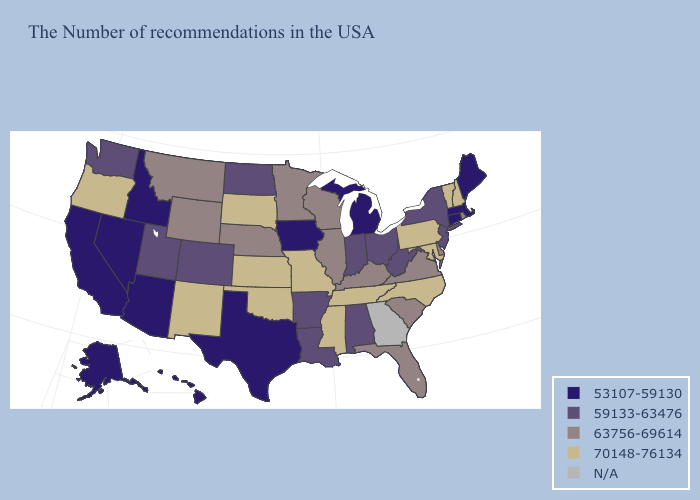Name the states that have a value in the range 70148-76134?
Be succinct. New Hampshire, Vermont, Maryland, Pennsylvania, North Carolina, Tennessee, Mississippi, Missouri, Kansas, Oklahoma, South Dakota, New Mexico, Oregon. What is the value of Minnesota?
Write a very short answer. 63756-69614. Name the states that have a value in the range 63756-69614?
Concise answer only. Rhode Island, Delaware, Virginia, South Carolina, Florida, Kentucky, Wisconsin, Illinois, Minnesota, Nebraska, Wyoming, Montana. What is the highest value in the West ?
Give a very brief answer. 70148-76134. What is the value of Wisconsin?
Short answer required. 63756-69614. Among the states that border Massachusetts , does New York have the highest value?
Write a very short answer. No. What is the value of New Hampshire?
Give a very brief answer. 70148-76134. Name the states that have a value in the range 59133-63476?
Concise answer only. New York, New Jersey, West Virginia, Ohio, Indiana, Alabama, Louisiana, Arkansas, North Dakota, Colorado, Utah, Washington. Does Maryland have the lowest value in the USA?
Give a very brief answer. No. Which states have the lowest value in the USA?
Keep it brief. Maine, Massachusetts, Connecticut, Michigan, Iowa, Texas, Arizona, Idaho, Nevada, California, Alaska, Hawaii. Is the legend a continuous bar?
Short answer required. No. Name the states that have a value in the range 70148-76134?
Answer briefly. New Hampshire, Vermont, Maryland, Pennsylvania, North Carolina, Tennessee, Mississippi, Missouri, Kansas, Oklahoma, South Dakota, New Mexico, Oregon. What is the value of California?
Keep it brief. 53107-59130. What is the value of Missouri?
Short answer required. 70148-76134. What is the highest value in states that border South Dakota?
Keep it brief. 63756-69614. 